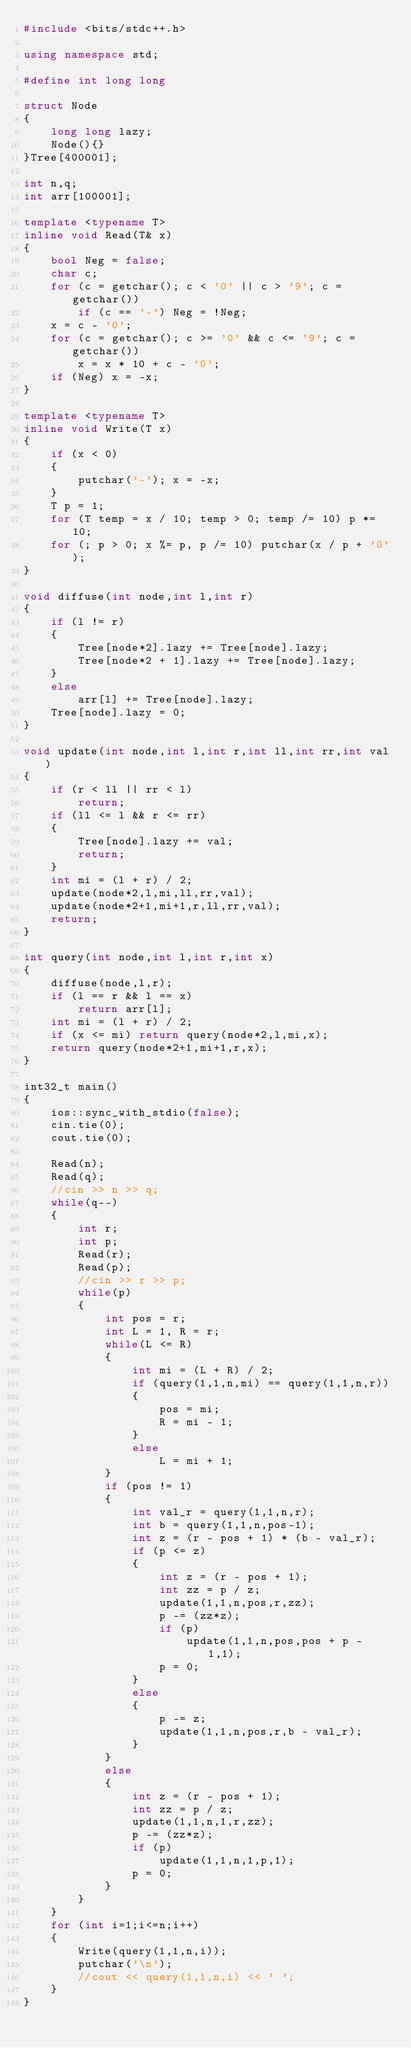Convert code to text. <code><loc_0><loc_0><loc_500><loc_500><_C++_>#include <bits/stdc++.h>

using namespace std;

#define int long long

struct Node
{
	long long lazy;
	Node(){}
}Tree[400001];

int n,q;
int arr[100001];

template <typename T>
inline void Read(T& x)
{
    bool Neg = false;
    char c;
    for (c = getchar(); c < '0' || c > '9'; c = getchar())
        if (c == '-') Neg = !Neg;
    x = c - '0';
    for (c = getchar(); c >= '0' && c <= '9'; c = getchar())
        x = x * 10 + c - '0';
    if (Neg) x = -x;
}

template <typename T>
inline void Write(T x)
{
    if (x < 0)
    {
        putchar('-'); x = -x;
    }
    T p = 1;
    for (T temp = x / 10; temp > 0; temp /= 10) p *= 10;
    for (; p > 0; x %= p, p /= 10) putchar(x / p + '0');
}

void diffuse(int node,int l,int r)
{
	if (l != r)
	{
		Tree[node*2].lazy += Tree[node].lazy;
		Tree[node*2 + 1].lazy += Tree[node].lazy;
	}
	else
		arr[l] += Tree[node].lazy;
	Tree[node].lazy = 0;			
}

void update(int node,int l,int r,int ll,int rr,int val)
{
	if (r < ll || rr < l)
		return;
	if (ll <= l && r <= rr)
	{
		Tree[node].lazy += val;
		return;
	}	
	int mi = (l + r) / 2;
	update(node*2,l,mi,ll,rr,val);
	update(node*2+1,mi+1,r,ll,rr,val);
	return;
}

int query(int node,int l,int r,int x)
{
	diffuse(node,l,r);
	if (l == r && l == x)
		return arr[l];	
	int mi = (l + r) / 2;
	if (x <= mi) return query(node*2,l,mi,x);
	return query(node*2+1,mi+1,r,x);
}

int32_t main()
{
	ios::sync_with_stdio(false);
	cin.tie(0);
	cout.tie(0);

	Read(n);
	Read(q);
	//cin >> n >> q;
	while(q--)
	{
		int r;
		int p;
		Read(r);
		Read(p);
		//cin >> r >> p;
		while(p)
		{
			int pos = r;
			int L = 1, R = r;
    		while(L <= R)
    		{
    			int mi = (L + R) / 2;
    			if (query(1,1,n,mi) == query(1,1,n,r))
    			{
    				pos = mi;
    				R = mi - 1;
    			}
    			else
    				L = mi + 1;
    		}
    		if (pos != 1)
    		{
    			int val_r = query(1,1,n,r);
    			int b = query(1,1,n,pos-1);
				int z = (r - pos + 1) * (b - val_r);
				if (p <= z)
				{
					int z = (r - pos + 1);
					int zz = p / z;
					update(1,1,n,pos,r,zz);
					p -= (zz*z);
					if (p)
						update(1,1,n,pos,pos + p - 1,1);
					p = 0; 
				}
				else
				{
					p -= z;
					update(1,1,n,pos,r,b - val_r);
				}	
			}
			else
			{
				int z = (r - pos + 1);
				int zz = p / z;
				update(1,1,n,1,r,zz);
				p -= (zz*z);
				if (p)
					update(1,1,n,1,p,1);
				p = 0;
			}	
		}
	}
	for (int i=1;i<=n;i++)
	{
		Write(query(1,1,n,i));
		putchar('\n');
		//cout << query(1,1,n,i) << ' ';
	}	
}</code> 